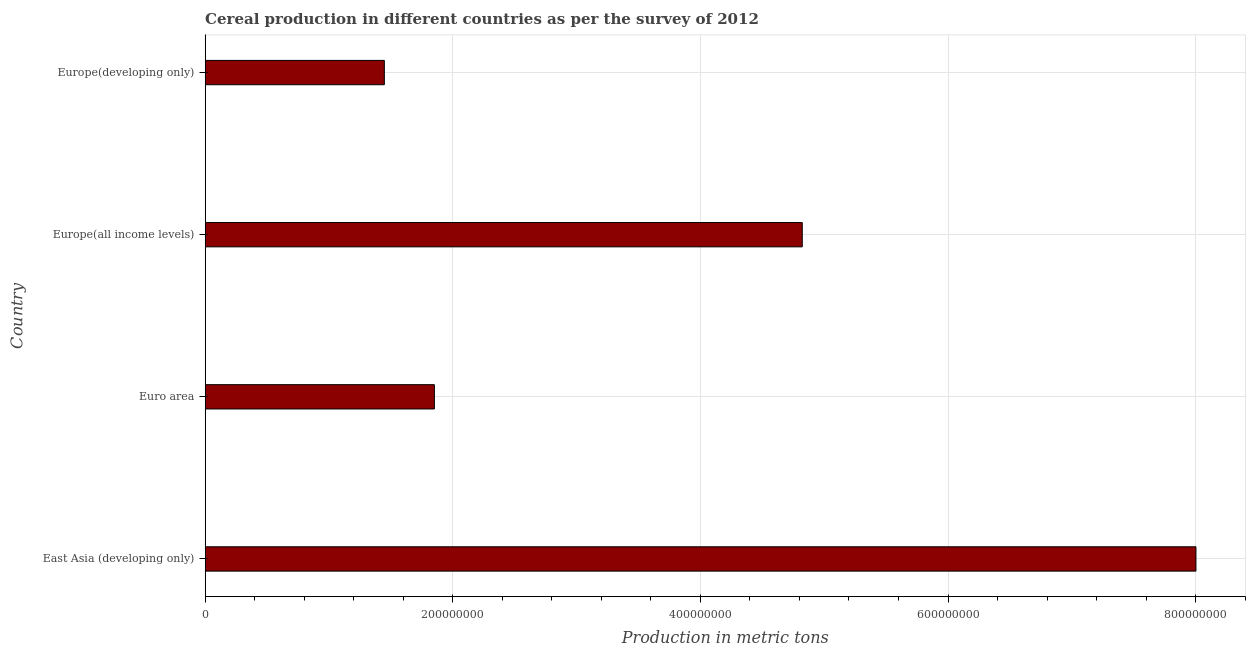Does the graph contain any zero values?
Give a very brief answer. No. What is the title of the graph?
Give a very brief answer. Cereal production in different countries as per the survey of 2012. What is the label or title of the X-axis?
Provide a short and direct response. Production in metric tons. What is the label or title of the Y-axis?
Provide a short and direct response. Country. What is the cereal production in Euro area?
Your answer should be compact. 1.85e+08. Across all countries, what is the maximum cereal production?
Give a very brief answer. 8.00e+08. Across all countries, what is the minimum cereal production?
Keep it short and to the point. 1.45e+08. In which country was the cereal production maximum?
Provide a short and direct response. East Asia (developing only). In which country was the cereal production minimum?
Ensure brevity in your answer.  Europe(developing only). What is the sum of the cereal production?
Your answer should be very brief. 1.61e+09. What is the difference between the cereal production in East Asia (developing only) and Europe(developing only)?
Provide a succinct answer. 6.56e+08. What is the average cereal production per country?
Give a very brief answer. 4.03e+08. What is the median cereal production?
Keep it short and to the point. 3.34e+08. What is the ratio of the cereal production in East Asia (developing only) to that in Europe(all income levels)?
Your answer should be very brief. 1.66. Is the cereal production in Euro area less than that in Europe(all income levels)?
Give a very brief answer. Yes. What is the difference between the highest and the second highest cereal production?
Offer a very short reply. 3.18e+08. What is the difference between the highest and the lowest cereal production?
Offer a very short reply. 6.56e+08. How many bars are there?
Provide a short and direct response. 4. What is the difference between two consecutive major ticks on the X-axis?
Provide a succinct answer. 2.00e+08. What is the Production in metric tons of East Asia (developing only)?
Ensure brevity in your answer.  8.00e+08. What is the Production in metric tons of Euro area?
Give a very brief answer. 1.85e+08. What is the Production in metric tons in Europe(all income levels)?
Provide a succinct answer. 4.82e+08. What is the Production in metric tons in Europe(developing only)?
Provide a short and direct response. 1.45e+08. What is the difference between the Production in metric tons in East Asia (developing only) and Euro area?
Your response must be concise. 6.15e+08. What is the difference between the Production in metric tons in East Asia (developing only) and Europe(all income levels)?
Your response must be concise. 3.18e+08. What is the difference between the Production in metric tons in East Asia (developing only) and Europe(developing only)?
Provide a short and direct response. 6.56e+08. What is the difference between the Production in metric tons in Euro area and Europe(all income levels)?
Your response must be concise. -2.97e+08. What is the difference between the Production in metric tons in Euro area and Europe(developing only)?
Ensure brevity in your answer.  4.04e+07. What is the difference between the Production in metric tons in Europe(all income levels) and Europe(developing only)?
Your response must be concise. 3.38e+08. What is the ratio of the Production in metric tons in East Asia (developing only) to that in Euro area?
Provide a succinct answer. 4.32. What is the ratio of the Production in metric tons in East Asia (developing only) to that in Europe(all income levels)?
Your answer should be very brief. 1.66. What is the ratio of the Production in metric tons in East Asia (developing only) to that in Europe(developing only)?
Provide a short and direct response. 5.53. What is the ratio of the Production in metric tons in Euro area to that in Europe(all income levels)?
Your answer should be very brief. 0.38. What is the ratio of the Production in metric tons in Euro area to that in Europe(developing only)?
Your response must be concise. 1.28. What is the ratio of the Production in metric tons in Europe(all income levels) to that in Europe(developing only)?
Your response must be concise. 3.33. 